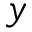<formula> <loc_0><loc_0><loc_500><loc_500>y</formula> 